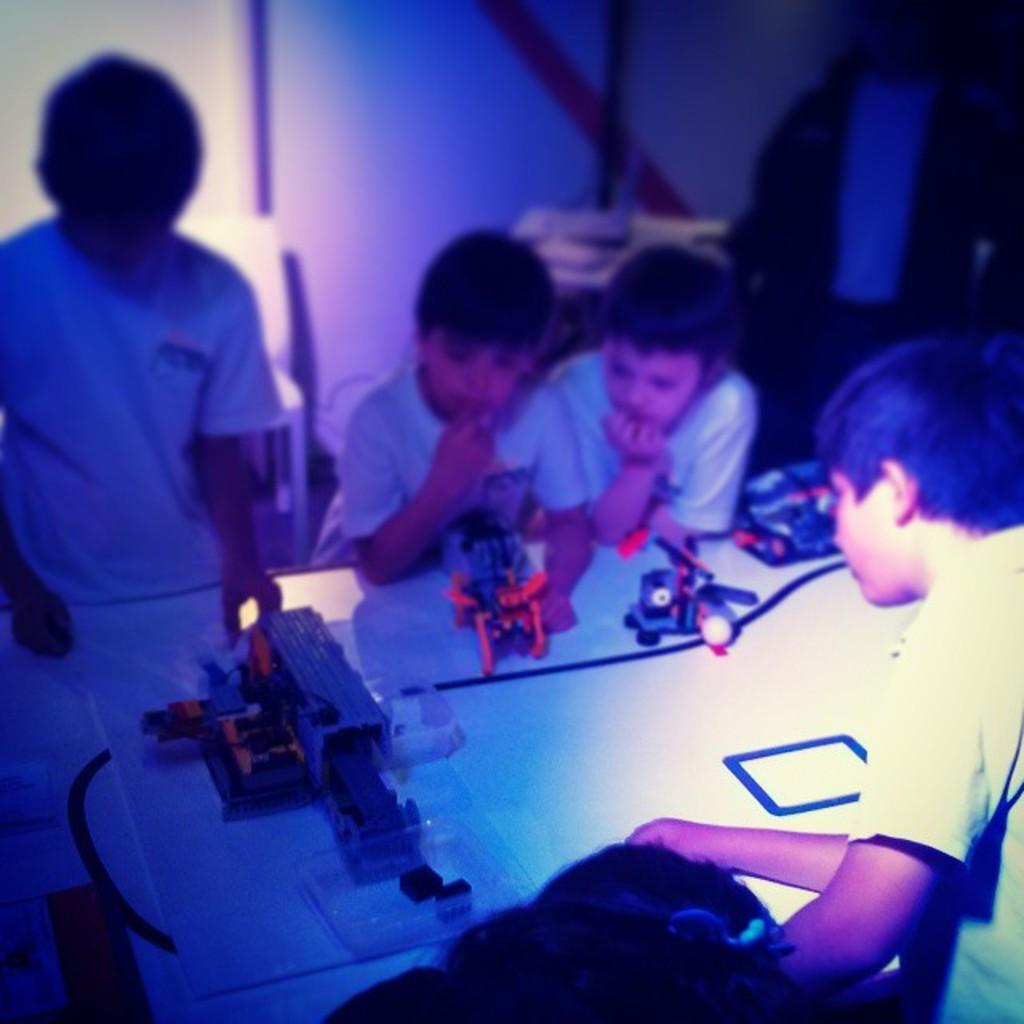What objects are on the table in the image? There are toys on a table in the image. Who is present around the table? There are children around the table in the image. Can you describe the person far from the table? There is a person far from the table in the image. What type of fruit is being smoked in a pipe in the image? There is no fruit or pipe present in the image. 